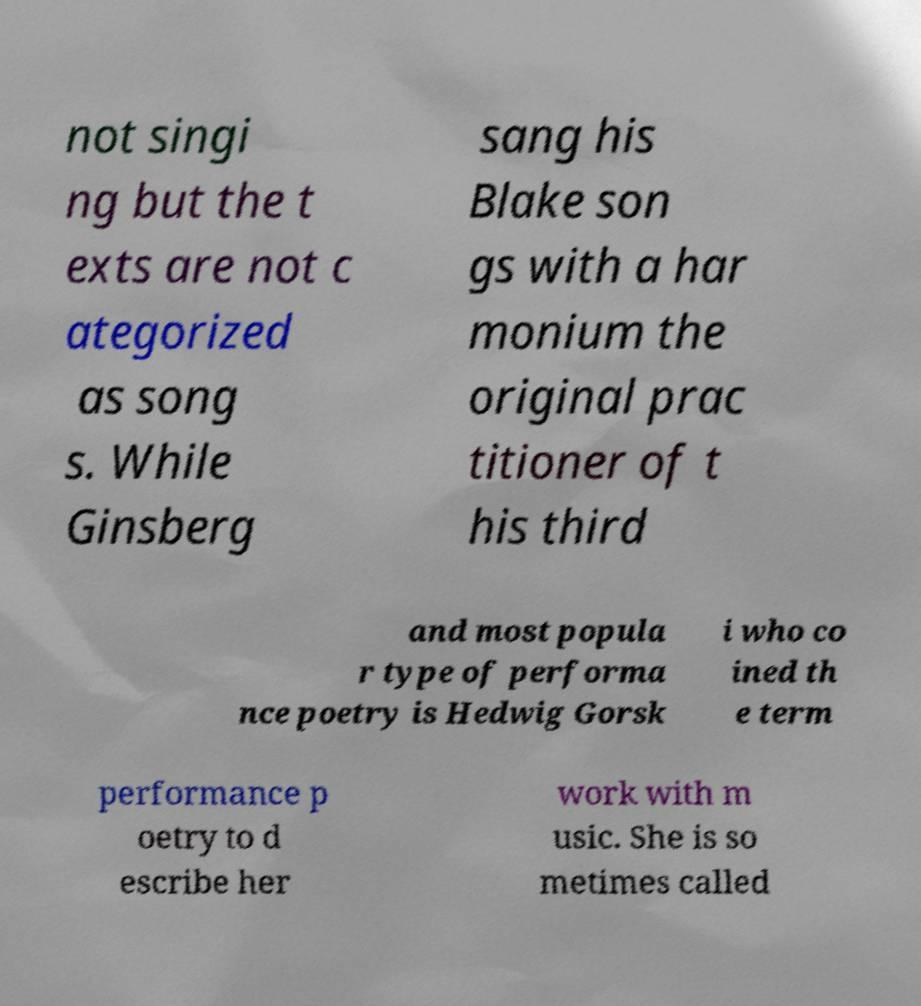Could you extract and type out the text from this image? not singi ng but the t exts are not c ategorized as song s. While Ginsberg sang his Blake son gs with a har monium the original prac titioner of t his third and most popula r type of performa nce poetry is Hedwig Gorsk i who co ined th e term performance p oetry to d escribe her work with m usic. She is so metimes called 